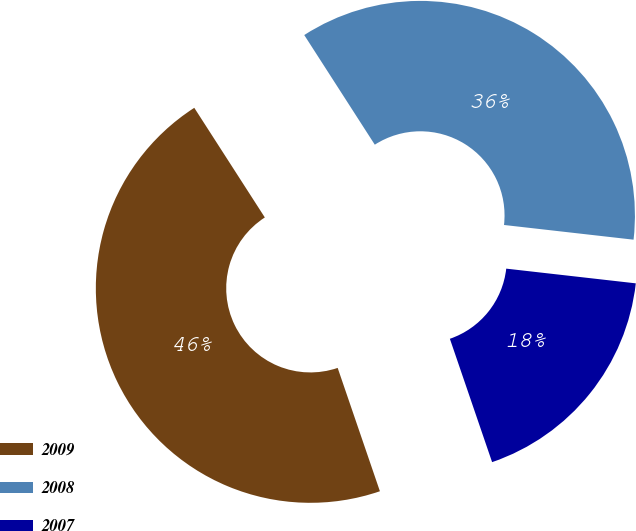Convert chart. <chart><loc_0><loc_0><loc_500><loc_500><pie_chart><fcel>2009<fcel>2008<fcel>2007<nl><fcel>46.15%<fcel>35.9%<fcel>17.95%<nl></chart> 